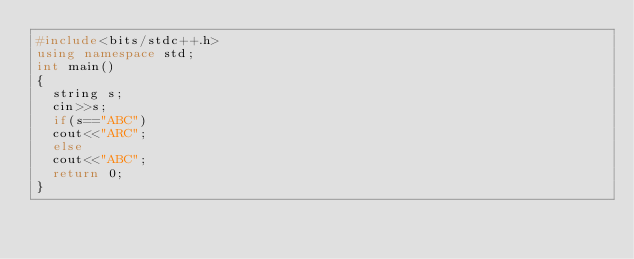Convert code to text. <code><loc_0><loc_0><loc_500><loc_500><_C++_>#include<bits/stdc++.h>
using namespace std;
int main()
{
	string s;
	cin>>s;
	if(s=="ABC")
	cout<<"ARC";
	else
	cout<<"ABC";
	return 0;
}</code> 